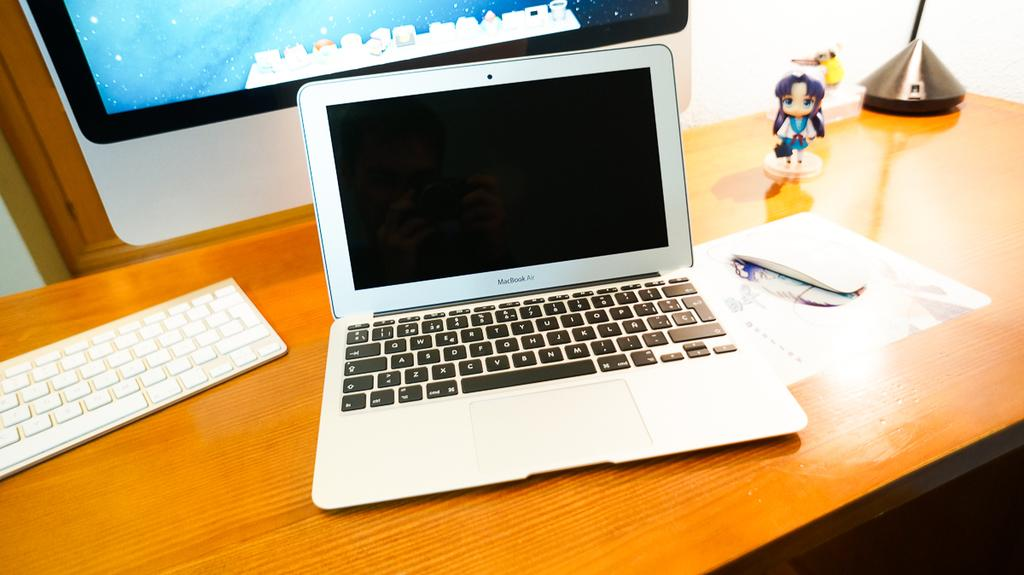<image>
Present a compact description of the photo's key features. a MacBook Air computer on a desk in front of a larger monitor 